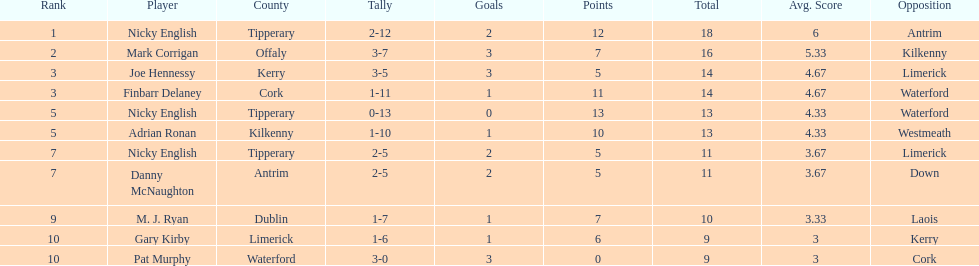How many points did both joe hennessy and finbarr delaney score? 14. Could you parse the entire table as a dict? {'header': ['Rank', 'Player', 'County', 'Tally', 'Goals', 'Points', 'Total', 'Avg. Score', 'Opposition'], 'rows': [['1', 'Nicky English', 'Tipperary', '2-12', '2', '12', '18', '6', 'Antrim'], ['2', 'Mark Corrigan', 'Offaly', '3-7', '3', '7', '16', '5.33', 'Kilkenny'], ['3', 'Joe Hennessy', 'Kerry', '3-5', '3', '5', '14', '4.67', 'Limerick'], ['3', 'Finbarr Delaney', 'Cork', '1-11', '1', '11', '14', '4.67', 'Waterford'], ['5', 'Nicky English', 'Tipperary', '0-13', '0', '13', '13', '4.33', 'Waterford'], ['5', 'Adrian Ronan', 'Kilkenny', '1-10', '1', '10', '13', '4.33', 'Westmeath'], ['7', 'Nicky English', 'Tipperary', '2-5', '2', '5', '11', '3.67', 'Limerick'], ['7', 'Danny McNaughton', 'Antrim', '2-5', '2', '5', '11', '3.67', 'Down'], ['9', 'M. J. Ryan', 'Dublin', '1-7', '1', '7', '10', '3.33', 'Laois'], ['10', 'Gary Kirby', 'Limerick', '1-6', '1', '6', '9', '3', 'Kerry'], ['10', 'Pat Murphy', 'Waterford', '3-0', '3', '0', '9', '3', 'Cork']]} 